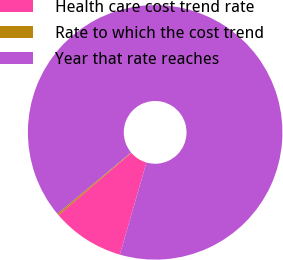Convert chart to OTSL. <chart><loc_0><loc_0><loc_500><loc_500><pie_chart><fcel>Health care cost trend rate<fcel>Rate to which the cost trend<fcel>Year that rate reaches<nl><fcel>9.25%<fcel>0.22%<fcel>90.52%<nl></chart> 